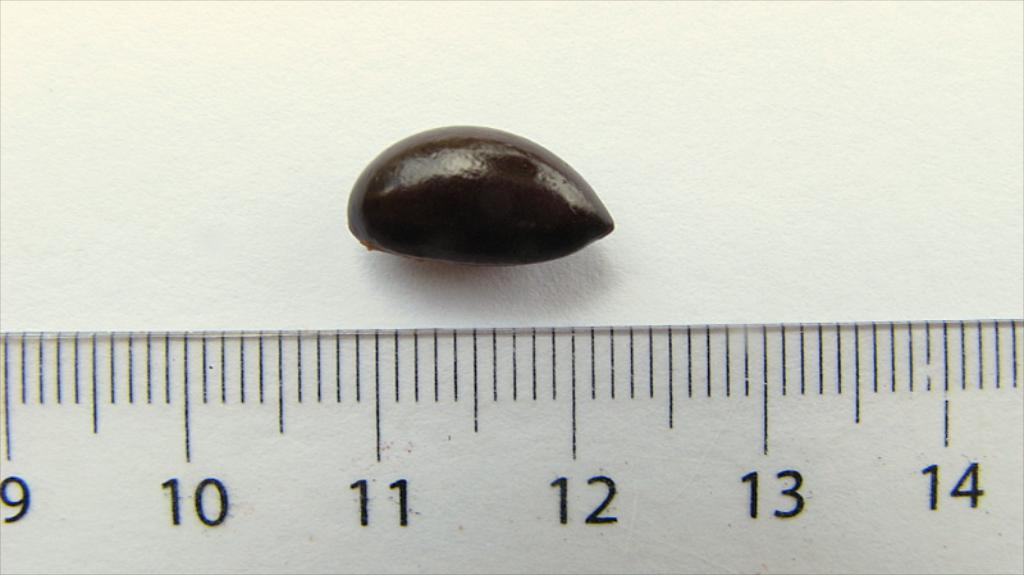Provide a one-sentence caption for the provided image. A small chocolate covered item of just over 1 inch in size is being measured by a ruler. 